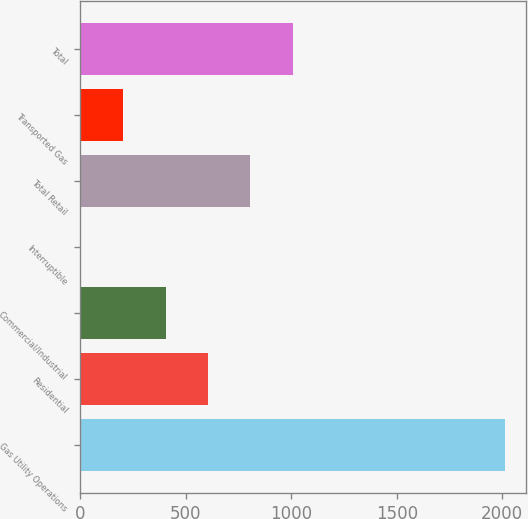Convert chart. <chart><loc_0><loc_0><loc_500><loc_500><bar_chart><fcel>Gas Utility Operations<fcel>Residential<fcel>Commercial/Industrial<fcel>Interruptible<fcel>Total Retail<fcel>Transported Gas<fcel>Total<nl><fcel>2012<fcel>604.79<fcel>403.76<fcel>1.7<fcel>805.82<fcel>202.73<fcel>1006.85<nl></chart> 